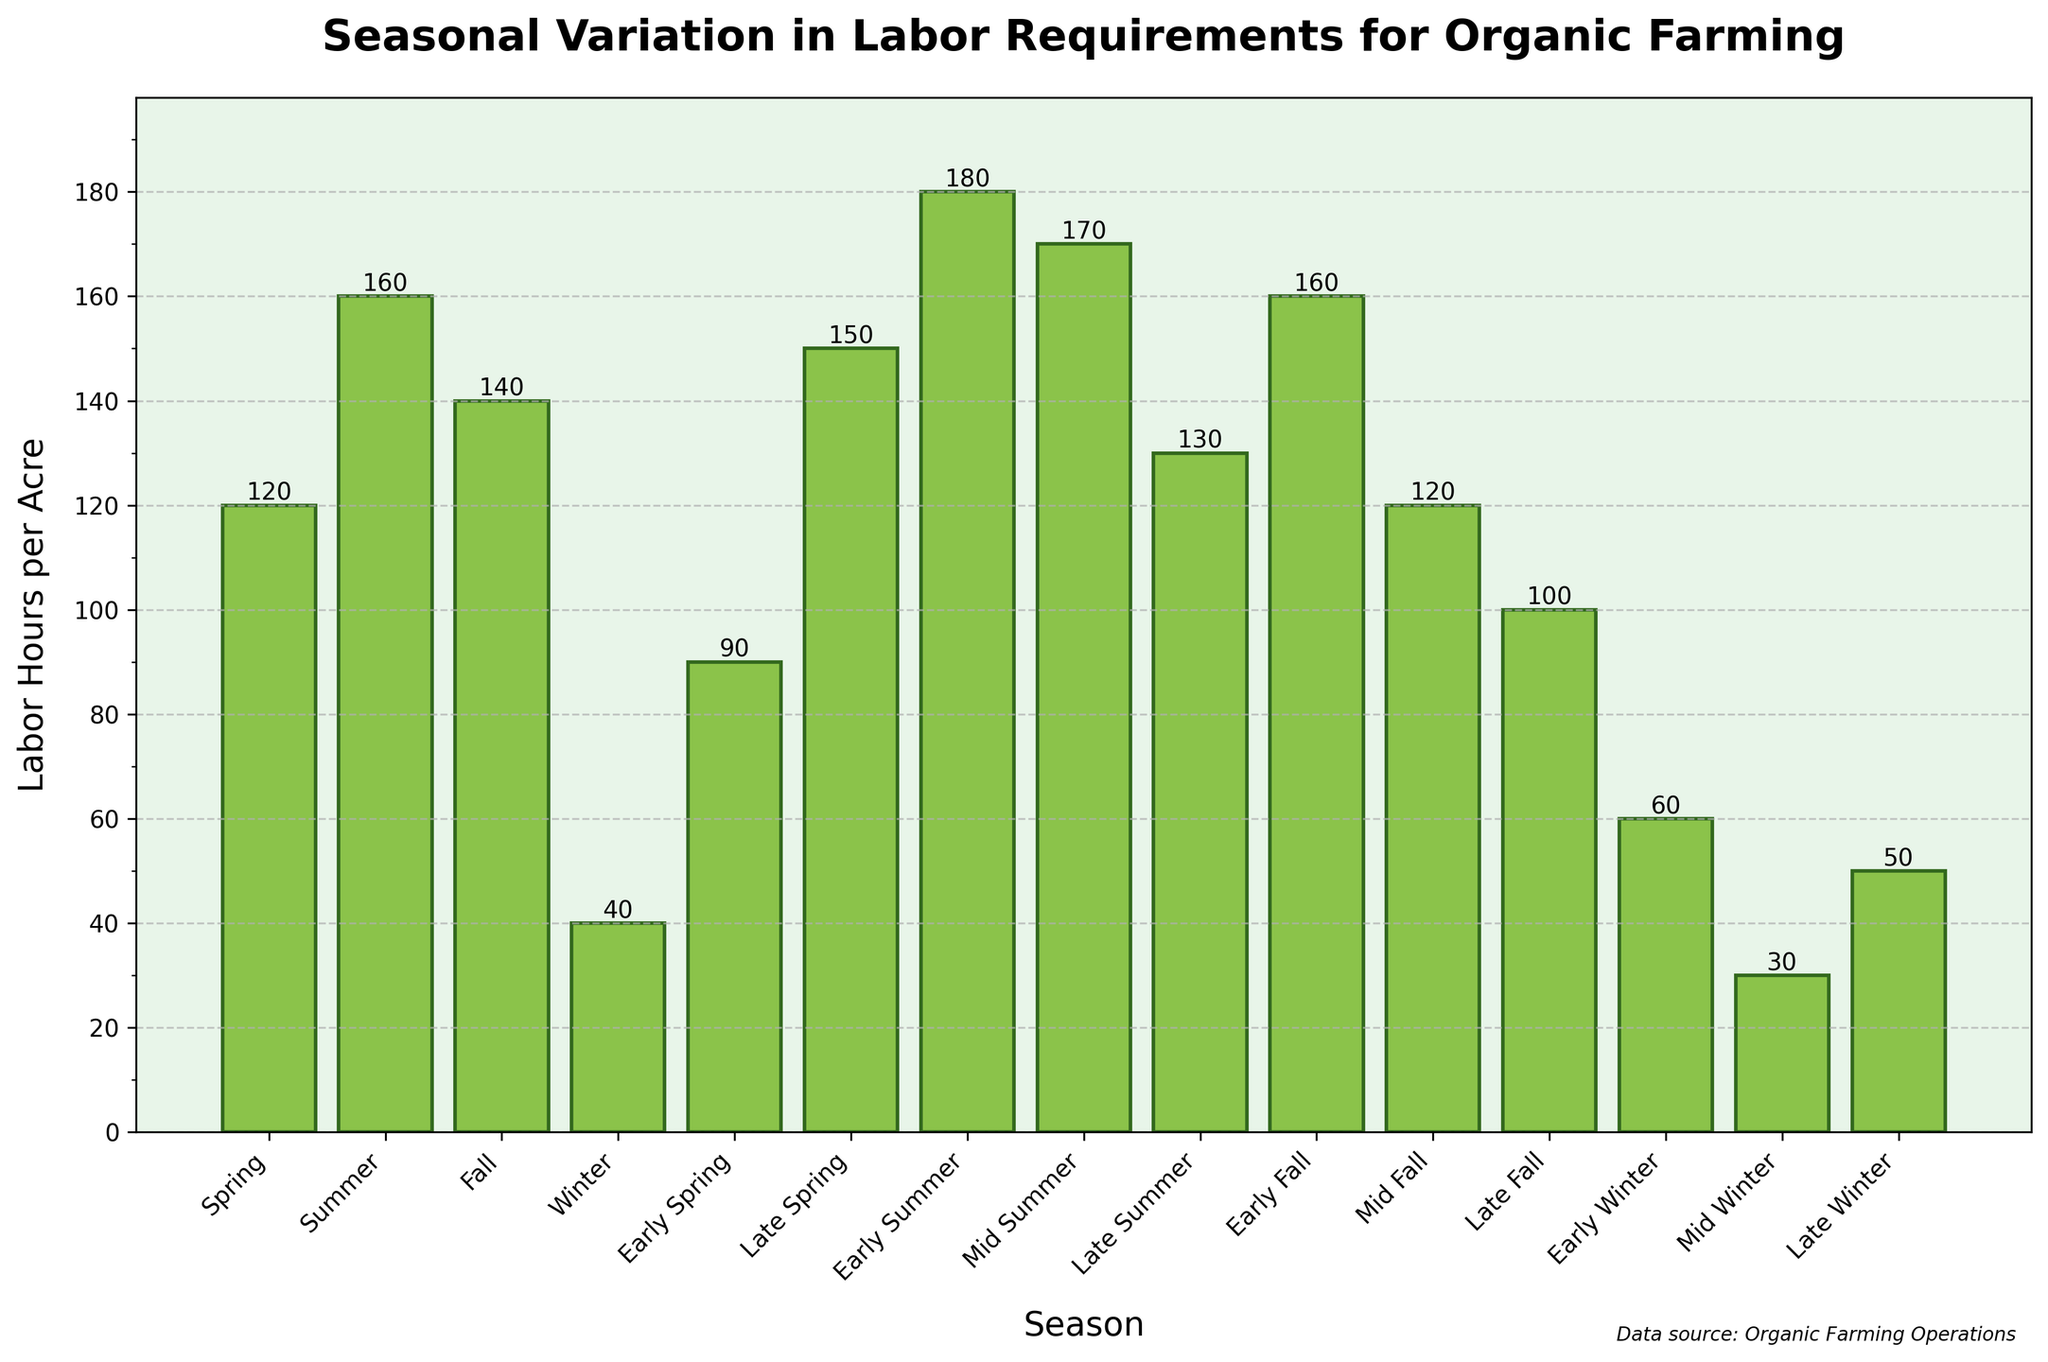what is the total labor hours required during Spring season (including Early Spring and Late Spring)? Add labor hours for Spring, Early Spring, and Late Spring: 120 + 90 + 150 = 360
Answer: 360 Which season requires more labor hours, Mid Fall or Early Summer? Compare labor hours: Mid Fall (120) vs Early Summer (180), Early Summer is higher.
Answer: Early Summer What is the average labor hours required for all Winter periods (Winter, Early Winter, Mid Winter, Late Winter)? Sum up labor hours and divide by the number of Winter periods: (40 + 60 + 30 + 50) / 4 = 180 / 4 = 45
Answer: 45 Which season has the lowest labor hours requirement? Identify the bar with the smallest height: Mid Winter (30).
Answer: Mid Winter How much more labor hours are required in Mid Summer compared to Late Summer? Difference between Mid Summer (170) and Late Summer (130): 170 - 130 = 40
Answer: 40 Which two seasons combined have the highest labor requirements? Add labor hours for all possible pairs and compare: Early Summer (180) + Spring (120) = 300, ... highest is Early Summer (180) + Mid Summer (170) = 350
Answer: Early Summer and Mid Summer What is the difference in labor hours between the highest and lowest labor requiring seasons? Highest is Early Summer (180), lowest is Mid Winter (30), difference is 180 - 30 = 150
Answer: 150 Which season has the second highest labor requirement? Identify the bar heights and rank them, second highest is Mid Summer (170)
Answer: Mid Summer How many more labor hours are required in Summer compared to Fall? Sum the labor hours for Summer: Early (180), Mid (170), and Late (130) = 480; for Fall: Early (160), Mid (120), and Late (100) = 380; difference is 480 - 380 = 100
Answer: 100 What is the labor hour requirement ratio between Summer and Winter? Total Summer hours is 480 and Winter is 180, ratio = 480 / 180 = 8 / 3 or approximately 2.67
Answer: Approximately 2.67 